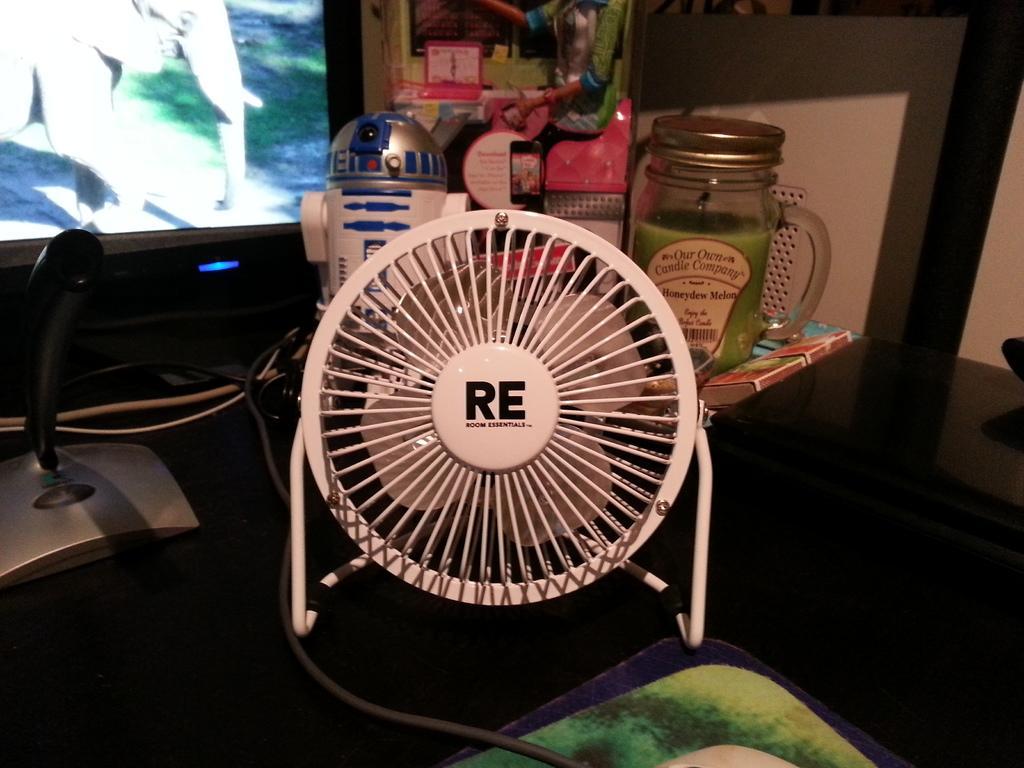Can you describe this image briefly? In this image we can see a jar, book, table fan, cables, clock and some other objects, also we can see a television and the wall, on the floor we can see a mat. 